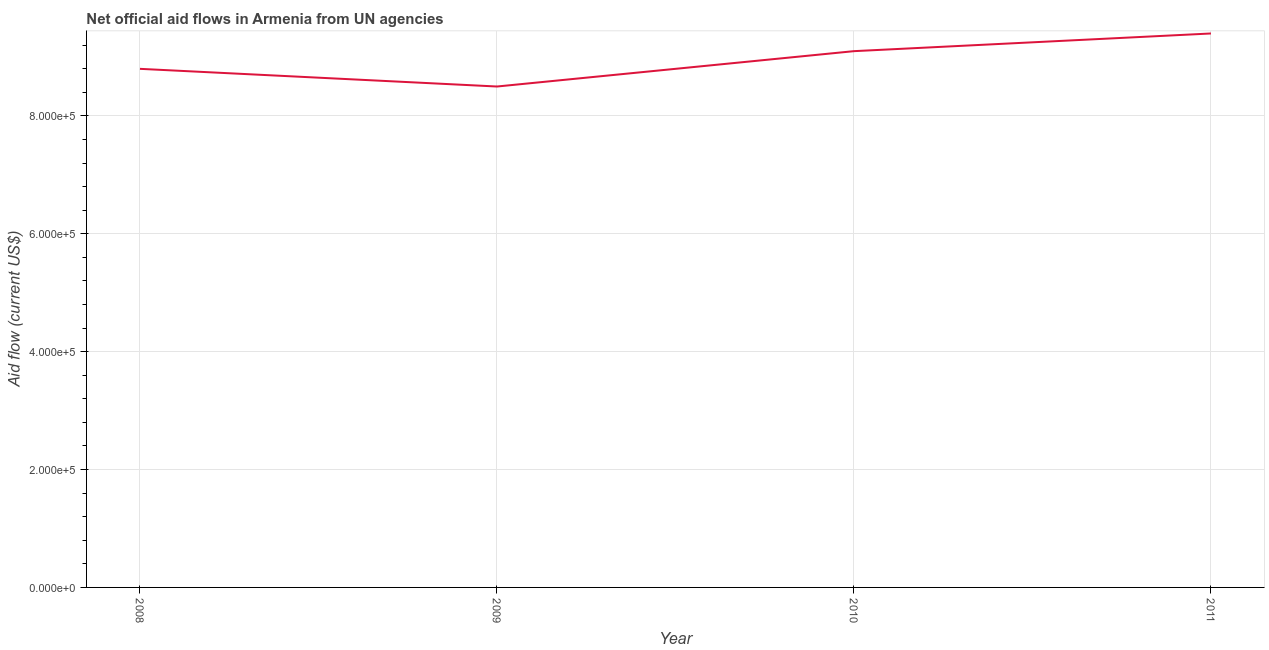What is the net official flows from un agencies in 2011?
Your response must be concise. 9.40e+05. Across all years, what is the maximum net official flows from un agencies?
Provide a succinct answer. 9.40e+05. Across all years, what is the minimum net official flows from un agencies?
Give a very brief answer. 8.50e+05. In which year was the net official flows from un agencies maximum?
Offer a terse response. 2011. What is the sum of the net official flows from un agencies?
Make the answer very short. 3.58e+06. What is the difference between the net official flows from un agencies in 2009 and 2010?
Ensure brevity in your answer.  -6.00e+04. What is the average net official flows from un agencies per year?
Make the answer very short. 8.95e+05. What is the median net official flows from un agencies?
Ensure brevity in your answer.  8.95e+05. In how many years, is the net official flows from un agencies greater than 40000 US$?
Provide a short and direct response. 4. Do a majority of the years between 2009 and 2010 (inclusive) have net official flows from un agencies greater than 480000 US$?
Keep it short and to the point. Yes. What is the ratio of the net official flows from un agencies in 2008 to that in 2011?
Provide a succinct answer. 0.94. What is the difference between the highest and the second highest net official flows from un agencies?
Give a very brief answer. 3.00e+04. What is the difference between the highest and the lowest net official flows from un agencies?
Keep it short and to the point. 9.00e+04. In how many years, is the net official flows from un agencies greater than the average net official flows from un agencies taken over all years?
Your response must be concise. 2. How many lines are there?
Your answer should be compact. 1. How many years are there in the graph?
Your response must be concise. 4. What is the difference between two consecutive major ticks on the Y-axis?
Offer a terse response. 2.00e+05. Does the graph contain grids?
Offer a very short reply. Yes. What is the title of the graph?
Ensure brevity in your answer.  Net official aid flows in Armenia from UN agencies. What is the Aid flow (current US$) of 2008?
Offer a terse response. 8.80e+05. What is the Aid flow (current US$) in 2009?
Your response must be concise. 8.50e+05. What is the Aid flow (current US$) in 2010?
Your response must be concise. 9.10e+05. What is the Aid flow (current US$) in 2011?
Your answer should be compact. 9.40e+05. What is the difference between the Aid flow (current US$) in 2008 and 2009?
Your answer should be compact. 3.00e+04. What is the difference between the Aid flow (current US$) in 2008 and 2010?
Make the answer very short. -3.00e+04. What is the ratio of the Aid flow (current US$) in 2008 to that in 2009?
Give a very brief answer. 1.03. What is the ratio of the Aid flow (current US$) in 2008 to that in 2011?
Make the answer very short. 0.94. What is the ratio of the Aid flow (current US$) in 2009 to that in 2010?
Your answer should be compact. 0.93. What is the ratio of the Aid flow (current US$) in 2009 to that in 2011?
Your response must be concise. 0.9. 